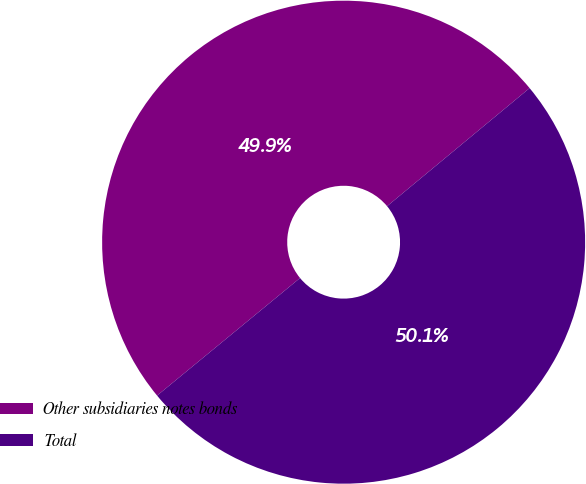<chart> <loc_0><loc_0><loc_500><loc_500><pie_chart><fcel>Other subsidiaries notes bonds<fcel>Total<nl><fcel>49.94%<fcel>50.06%<nl></chart> 